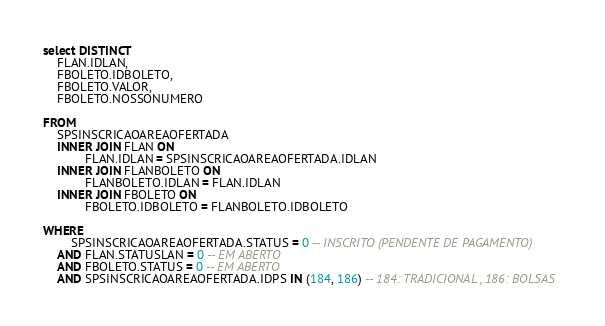Convert code to text. <code><loc_0><loc_0><loc_500><loc_500><_SQL_>select DISTINCT
	FLAN.IDLAN,
	FBOLETO.IDBOLETO,
	FBOLETO.VALOR,
	FBOLETO.NOSSONUMERO

FROM
	SPSINSCRICAOAREAOFERTADA
	INNER JOIN FLAN ON 
			FLAN.IDLAN = SPSINSCRICAOAREAOFERTADA.IDLAN
	INNER JOIN FLANBOLETO ON
			FLANBOLETO.IDLAN = FLAN.IDLAN
	INNER JOIN FBOLETO ON
			FBOLETO.IDBOLETO = FLANBOLETO.IDBOLETO

WHERE 
		SPSINSCRICAOAREAOFERTADA.STATUS = 0 -- INSCRITO (PENDENTE DE PAGAMENTO)
	AND FLAN.STATUSLAN = 0 -- EM ABERTO
	AND FBOLETO.STATUS = 0 -- EM ABERTO 
	AND SPSINSCRICAOAREAOFERTADA.IDPS IN (184, 186) -- 184: TRADICIONAL , 186: BOLSAS
</code> 